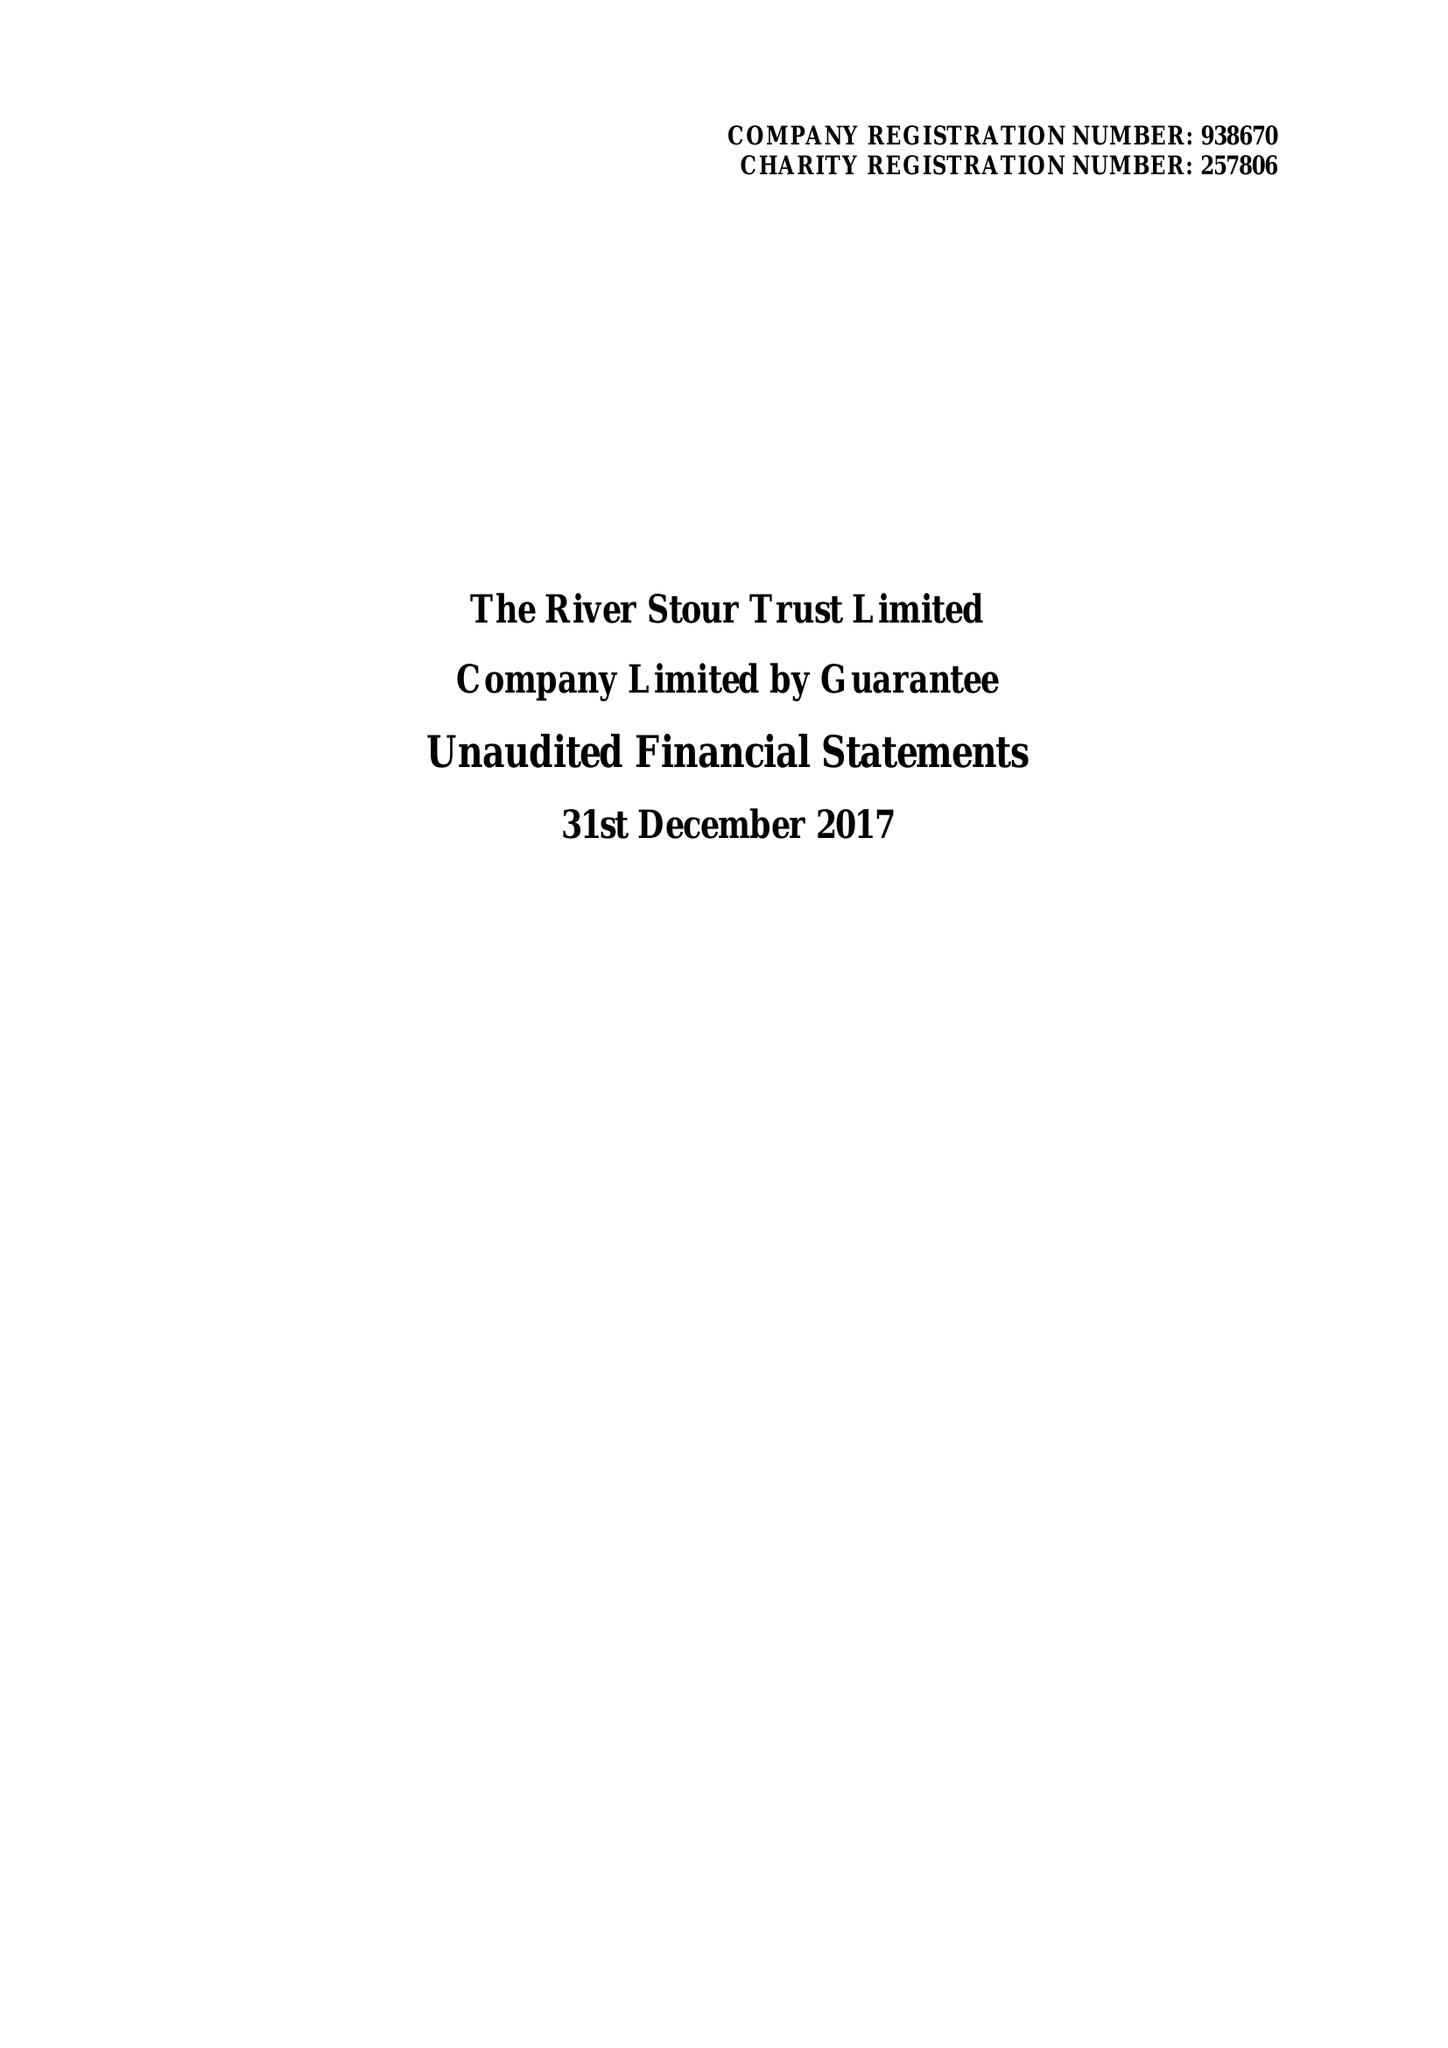What is the value for the charity_name?
Answer the question using a single word or phrase. The River Stour Trust Ltd. 